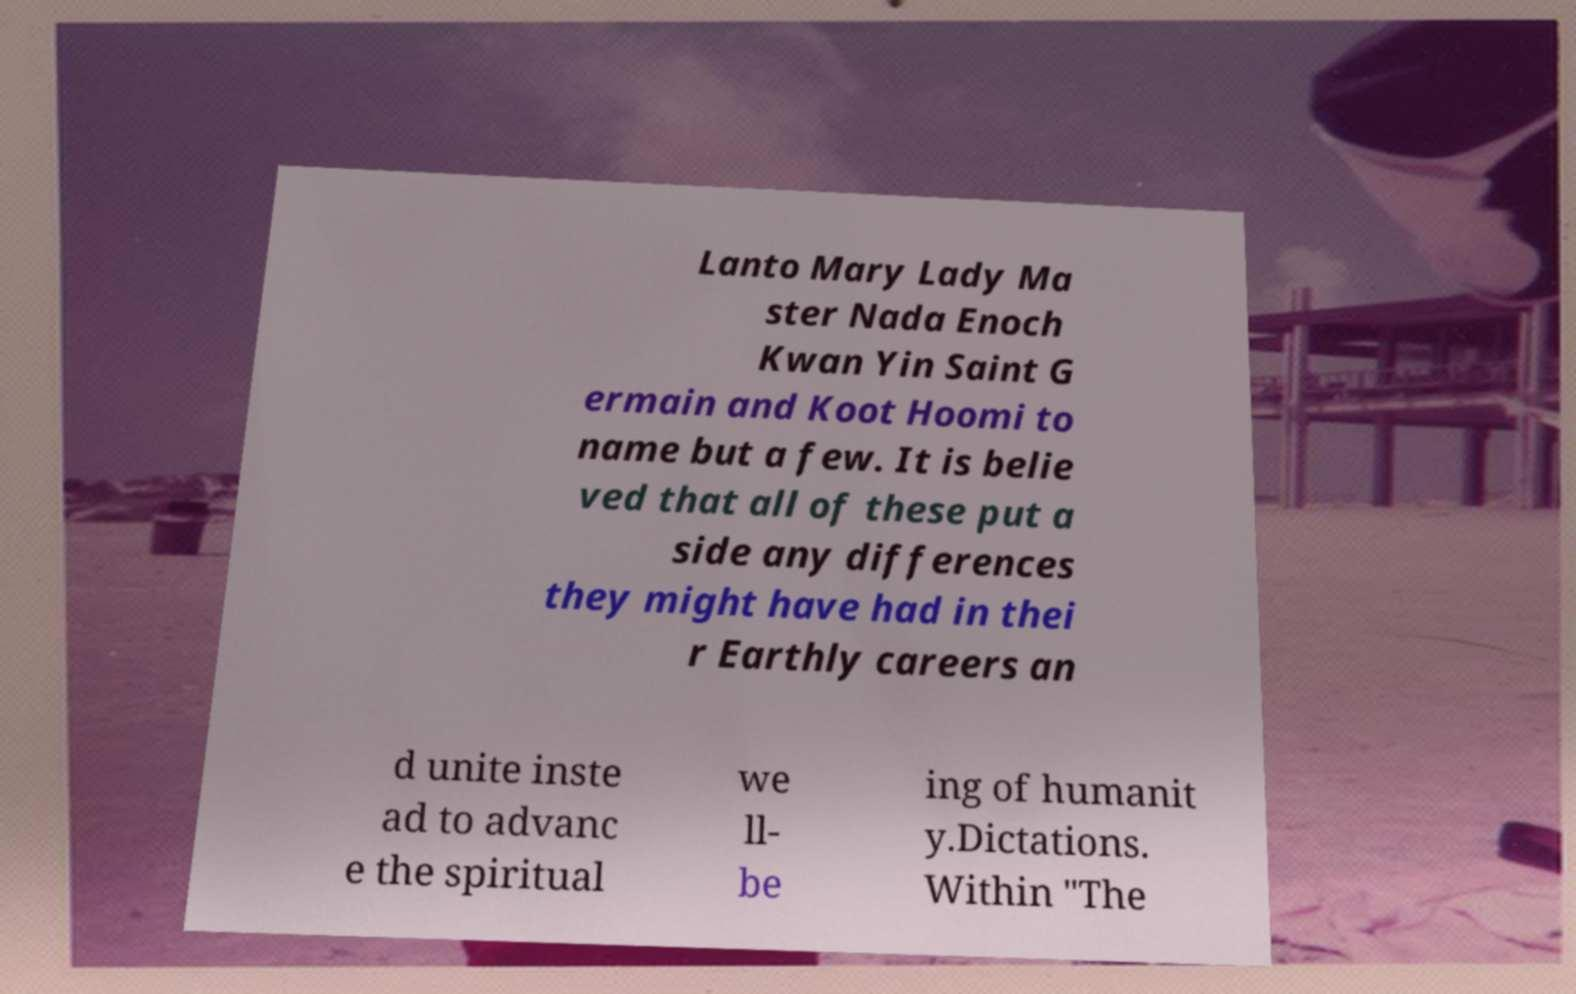Please identify and transcribe the text found in this image. Lanto Mary Lady Ma ster Nada Enoch Kwan Yin Saint G ermain and Koot Hoomi to name but a few. It is belie ved that all of these put a side any differences they might have had in thei r Earthly careers an d unite inste ad to advanc e the spiritual we ll- be ing of humanit y.Dictations. Within "The 